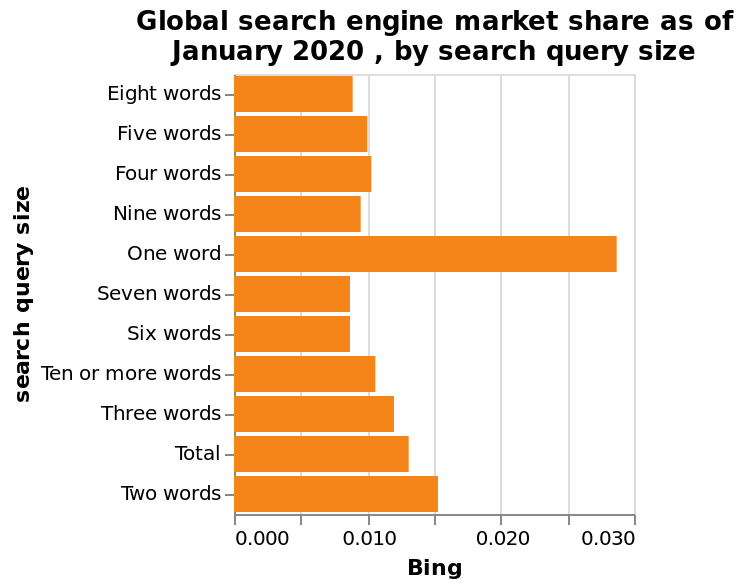<image>
What does the bar diagram display? The bar diagram displays the global market share of search engines based on search query size. What is the popularity ratio between one-word and six or seven-word queries on Bing? One-word queries on Bing are approximately three times more popular than six or seven-word queries. What is the title of the bar diagram?  The title of the bar diagram is "Global search engine market share as of January 2020, by search query size." Offer a thorough analysis of the image. The most popular queries on Bing have only one word. This is around three times higher than the least popular queries which have six or seven words. The second most popular queries on Bing have two words which is around half as popular as the one-word queries. How popular are one-word queries compared to two-word queries on Bing?  One-word queries are around three times more popular than two-word queries on Bing. 